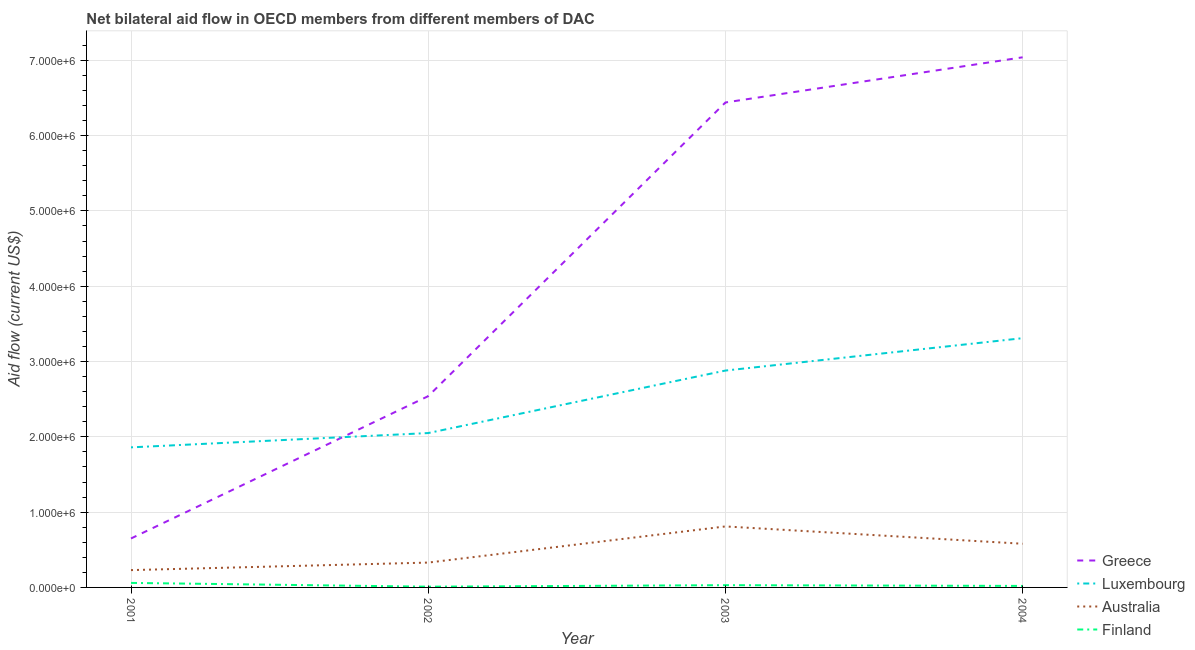Does the line corresponding to amount of aid given by luxembourg intersect with the line corresponding to amount of aid given by finland?
Offer a terse response. No. Is the number of lines equal to the number of legend labels?
Make the answer very short. Yes. What is the amount of aid given by australia in 2004?
Your answer should be very brief. 5.80e+05. Across all years, what is the maximum amount of aid given by finland?
Offer a very short reply. 6.00e+04. Across all years, what is the minimum amount of aid given by luxembourg?
Your response must be concise. 1.86e+06. In which year was the amount of aid given by greece minimum?
Your answer should be compact. 2001. What is the total amount of aid given by australia in the graph?
Give a very brief answer. 1.95e+06. What is the difference between the amount of aid given by luxembourg in 2002 and that in 2004?
Your answer should be compact. -1.26e+06. What is the difference between the amount of aid given by finland in 2002 and the amount of aid given by luxembourg in 2004?
Offer a very short reply. -3.30e+06. What is the average amount of aid given by luxembourg per year?
Provide a succinct answer. 2.52e+06. In the year 2001, what is the difference between the amount of aid given by luxembourg and amount of aid given by finland?
Offer a terse response. 1.80e+06. What is the ratio of the amount of aid given by finland in 2003 to that in 2004?
Make the answer very short. 1.5. Is the difference between the amount of aid given by luxembourg in 2001 and 2002 greater than the difference between the amount of aid given by greece in 2001 and 2002?
Provide a succinct answer. Yes. What is the difference between the highest and the lowest amount of aid given by luxembourg?
Your answer should be very brief. 1.45e+06. Is the sum of the amount of aid given by australia in 2001 and 2002 greater than the maximum amount of aid given by greece across all years?
Give a very brief answer. No. Is it the case that in every year, the sum of the amount of aid given by greece and amount of aid given by luxembourg is greater than the amount of aid given by australia?
Offer a terse response. Yes. Is the amount of aid given by australia strictly less than the amount of aid given by finland over the years?
Your response must be concise. No. How many lines are there?
Make the answer very short. 4. How many years are there in the graph?
Make the answer very short. 4. What is the difference between two consecutive major ticks on the Y-axis?
Provide a short and direct response. 1.00e+06. Does the graph contain any zero values?
Offer a very short reply. No. Does the graph contain grids?
Make the answer very short. Yes. How many legend labels are there?
Provide a short and direct response. 4. How are the legend labels stacked?
Make the answer very short. Vertical. What is the title of the graph?
Make the answer very short. Net bilateral aid flow in OECD members from different members of DAC. What is the label or title of the X-axis?
Give a very brief answer. Year. What is the label or title of the Y-axis?
Your answer should be compact. Aid flow (current US$). What is the Aid flow (current US$) of Greece in 2001?
Give a very brief answer. 6.50e+05. What is the Aid flow (current US$) of Luxembourg in 2001?
Your answer should be very brief. 1.86e+06. What is the Aid flow (current US$) of Australia in 2001?
Give a very brief answer. 2.30e+05. What is the Aid flow (current US$) in Finland in 2001?
Give a very brief answer. 6.00e+04. What is the Aid flow (current US$) of Greece in 2002?
Your answer should be compact. 2.54e+06. What is the Aid flow (current US$) of Luxembourg in 2002?
Your answer should be very brief. 2.05e+06. What is the Aid flow (current US$) of Australia in 2002?
Your answer should be compact. 3.30e+05. What is the Aid flow (current US$) in Finland in 2002?
Offer a very short reply. 10000. What is the Aid flow (current US$) in Greece in 2003?
Your response must be concise. 6.44e+06. What is the Aid flow (current US$) of Luxembourg in 2003?
Offer a terse response. 2.88e+06. What is the Aid flow (current US$) in Australia in 2003?
Make the answer very short. 8.10e+05. What is the Aid flow (current US$) in Greece in 2004?
Provide a succinct answer. 7.04e+06. What is the Aid flow (current US$) in Luxembourg in 2004?
Your response must be concise. 3.31e+06. What is the Aid flow (current US$) in Australia in 2004?
Offer a terse response. 5.80e+05. What is the Aid flow (current US$) in Finland in 2004?
Offer a very short reply. 2.00e+04. Across all years, what is the maximum Aid flow (current US$) in Greece?
Give a very brief answer. 7.04e+06. Across all years, what is the maximum Aid flow (current US$) of Luxembourg?
Provide a short and direct response. 3.31e+06. Across all years, what is the maximum Aid flow (current US$) in Australia?
Offer a terse response. 8.10e+05. Across all years, what is the maximum Aid flow (current US$) of Finland?
Give a very brief answer. 6.00e+04. Across all years, what is the minimum Aid flow (current US$) in Greece?
Ensure brevity in your answer.  6.50e+05. Across all years, what is the minimum Aid flow (current US$) of Luxembourg?
Offer a very short reply. 1.86e+06. What is the total Aid flow (current US$) in Greece in the graph?
Your answer should be very brief. 1.67e+07. What is the total Aid flow (current US$) in Luxembourg in the graph?
Make the answer very short. 1.01e+07. What is the total Aid flow (current US$) in Australia in the graph?
Offer a terse response. 1.95e+06. What is the total Aid flow (current US$) of Finland in the graph?
Ensure brevity in your answer.  1.20e+05. What is the difference between the Aid flow (current US$) in Greece in 2001 and that in 2002?
Offer a very short reply. -1.89e+06. What is the difference between the Aid flow (current US$) in Luxembourg in 2001 and that in 2002?
Provide a succinct answer. -1.90e+05. What is the difference between the Aid flow (current US$) in Greece in 2001 and that in 2003?
Provide a short and direct response. -5.79e+06. What is the difference between the Aid flow (current US$) of Luxembourg in 2001 and that in 2003?
Offer a very short reply. -1.02e+06. What is the difference between the Aid flow (current US$) in Australia in 2001 and that in 2003?
Ensure brevity in your answer.  -5.80e+05. What is the difference between the Aid flow (current US$) in Finland in 2001 and that in 2003?
Offer a very short reply. 3.00e+04. What is the difference between the Aid flow (current US$) in Greece in 2001 and that in 2004?
Offer a very short reply. -6.39e+06. What is the difference between the Aid flow (current US$) of Luxembourg in 2001 and that in 2004?
Your response must be concise. -1.45e+06. What is the difference between the Aid flow (current US$) of Australia in 2001 and that in 2004?
Make the answer very short. -3.50e+05. What is the difference between the Aid flow (current US$) in Greece in 2002 and that in 2003?
Your answer should be compact. -3.90e+06. What is the difference between the Aid flow (current US$) of Luxembourg in 2002 and that in 2003?
Offer a very short reply. -8.30e+05. What is the difference between the Aid flow (current US$) in Australia in 2002 and that in 2003?
Ensure brevity in your answer.  -4.80e+05. What is the difference between the Aid flow (current US$) in Greece in 2002 and that in 2004?
Provide a succinct answer. -4.50e+06. What is the difference between the Aid flow (current US$) of Luxembourg in 2002 and that in 2004?
Your answer should be very brief. -1.26e+06. What is the difference between the Aid flow (current US$) in Greece in 2003 and that in 2004?
Make the answer very short. -6.00e+05. What is the difference between the Aid flow (current US$) in Luxembourg in 2003 and that in 2004?
Your response must be concise. -4.30e+05. What is the difference between the Aid flow (current US$) of Australia in 2003 and that in 2004?
Your answer should be very brief. 2.30e+05. What is the difference between the Aid flow (current US$) of Greece in 2001 and the Aid flow (current US$) of Luxembourg in 2002?
Make the answer very short. -1.40e+06. What is the difference between the Aid flow (current US$) of Greece in 2001 and the Aid flow (current US$) of Finland in 2002?
Provide a succinct answer. 6.40e+05. What is the difference between the Aid flow (current US$) of Luxembourg in 2001 and the Aid flow (current US$) of Australia in 2002?
Your answer should be very brief. 1.53e+06. What is the difference between the Aid flow (current US$) of Luxembourg in 2001 and the Aid flow (current US$) of Finland in 2002?
Give a very brief answer. 1.85e+06. What is the difference between the Aid flow (current US$) of Greece in 2001 and the Aid flow (current US$) of Luxembourg in 2003?
Your answer should be very brief. -2.23e+06. What is the difference between the Aid flow (current US$) of Greece in 2001 and the Aid flow (current US$) of Australia in 2003?
Offer a very short reply. -1.60e+05. What is the difference between the Aid flow (current US$) of Greece in 2001 and the Aid flow (current US$) of Finland in 2003?
Give a very brief answer. 6.20e+05. What is the difference between the Aid flow (current US$) of Luxembourg in 2001 and the Aid flow (current US$) of Australia in 2003?
Your response must be concise. 1.05e+06. What is the difference between the Aid flow (current US$) of Luxembourg in 2001 and the Aid flow (current US$) of Finland in 2003?
Your answer should be very brief. 1.83e+06. What is the difference between the Aid flow (current US$) in Australia in 2001 and the Aid flow (current US$) in Finland in 2003?
Make the answer very short. 2.00e+05. What is the difference between the Aid flow (current US$) in Greece in 2001 and the Aid flow (current US$) in Luxembourg in 2004?
Give a very brief answer. -2.66e+06. What is the difference between the Aid flow (current US$) in Greece in 2001 and the Aid flow (current US$) in Finland in 2004?
Provide a short and direct response. 6.30e+05. What is the difference between the Aid flow (current US$) of Luxembourg in 2001 and the Aid flow (current US$) of Australia in 2004?
Your answer should be compact. 1.28e+06. What is the difference between the Aid flow (current US$) of Luxembourg in 2001 and the Aid flow (current US$) of Finland in 2004?
Provide a short and direct response. 1.84e+06. What is the difference between the Aid flow (current US$) of Australia in 2001 and the Aid flow (current US$) of Finland in 2004?
Offer a terse response. 2.10e+05. What is the difference between the Aid flow (current US$) in Greece in 2002 and the Aid flow (current US$) in Australia in 2003?
Offer a terse response. 1.73e+06. What is the difference between the Aid flow (current US$) of Greece in 2002 and the Aid flow (current US$) of Finland in 2003?
Provide a succinct answer. 2.51e+06. What is the difference between the Aid flow (current US$) in Luxembourg in 2002 and the Aid flow (current US$) in Australia in 2003?
Make the answer very short. 1.24e+06. What is the difference between the Aid flow (current US$) in Luxembourg in 2002 and the Aid flow (current US$) in Finland in 2003?
Offer a very short reply. 2.02e+06. What is the difference between the Aid flow (current US$) of Greece in 2002 and the Aid flow (current US$) of Luxembourg in 2004?
Offer a terse response. -7.70e+05. What is the difference between the Aid flow (current US$) of Greece in 2002 and the Aid flow (current US$) of Australia in 2004?
Give a very brief answer. 1.96e+06. What is the difference between the Aid flow (current US$) in Greece in 2002 and the Aid flow (current US$) in Finland in 2004?
Provide a succinct answer. 2.52e+06. What is the difference between the Aid flow (current US$) of Luxembourg in 2002 and the Aid flow (current US$) of Australia in 2004?
Make the answer very short. 1.47e+06. What is the difference between the Aid flow (current US$) of Luxembourg in 2002 and the Aid flow (current US$) of Finland in 2004?
Your response must be concise. 2.03e+06. What is the difference between the Aid flow (current US$) of Australia in 2002 and the Aid flow (current US$) of Finland in 2004?
Give a very brief answer. 3.10e+05. What is the difference between the Aid flow (current US$) of Greece in 2003 and the Aid flow (current US$) of Luxembourg in 2004?
Offer a terse response. 3.13e+06. What is the difference between the Aid flow (current US$) of Greece in 2003 and the Aid flow (current US$) of Australia in 2004?
Provide a succinct answer. 5.86e+06. What is the difference between the Aid flow (current US$) of Greece in 2003 and the Aid flow (current US$) of Finland in 2004?
Your answer should be very brief. 6.42e+06. What is the difference between the Aid flow (current US$) of Luxembourg in 2003 and the Aid flow (current US$) of Australia in 2004?
Give a very brief answer. 2.30e+06. What is the difference between the Aid flow (current US$) of Luxembourg in 2003 and the Aid flow (current US$) of Finland in 2004?
Keep it short and to the point. 2.86e+06. What is the difference between the Aid flow (current US$) in Australia in 2003 and the Aid flow (current US$) in Finland in 2004?
Offer a terse response. 7.90e+05. What is the average Aid flow (current US$) in Greece per year?
Offer a very short reply. 4.17e+06. What is the average Aid flow (current US$) in Luxembourg per year?
Ensure brevity in your answer.  2.52e+06. What is the average Aid flow (current US$) in Australia per year?
Provide a short and direct response. 4.88e+05. What is the average Aid flow (current US$) of Finland per year?
Give a very brief answer. 3.00e+04. In the year 2001, what is the difference between the Aid flow (current US$) of Greece and Aid flow (current US$) of Luxembourg?
Your answer should be very brief. -1.21e+06. In the year 2001, what is the difference between the Aid flow (current US$) of Greece and Aid flow (current US$) of Finland?
Provide a succinct answer. 5.90e+05. In the year 2001, what is the difference between the Aid flow (current US$) of Luxembourg and Aid flow (current US$) of Australia?
Your answer should be very brief. 1.63e+06. In the year 2001, what is the difference between the Aid flow (current US$) in Luxembourg and Aid flow (current US$) in Finland?
Your response must be concise. 1.80e+06. In the year 2001, what is the difference between the Aid flow (current US$) of Australia and Aid flow (current US$) of Finland?
Ensure brevity in your answer.  1.70e+05. In the year 2002, what is the difference between the Aid flow (current US$) of Greece and Aid flow (current US$) of Luxembourg?
Offer a very short reply. 4.90e+05. In the year 2002, what is the difference between the Aid flow (current US$) of Greece and Aid flow (current US$) of Australia?
Ensure brevity in your answer.  2.21e+06. In the year 2002, what is the difference between the Aid flow (current US$) of Greece and Aid flow (current US$) of Finland?
Offer a terse response. 2.53e+06. In the year 2002, what is the difference between the Aid flow (current US$) of Luxembourg and Aid flow (current US$) of Australia?
Your answer should be compact. 1.72e+06. In the year 2002, what is the difference between the Aid flow (current US$) of Luxembourg and Aid flow (current US$) of Finland?
Your answer should be very brief. 2.04e+06. In the year 2002, what is the difference between the Aid flow (current US$) of Australia and Aid flow (current US$) of Finland?
Provide a succinct answer. 3.20e+05. In the year 2003, what is the difference between the Aid flow (current US$) in Greece and Aid flow (current US$) in Luxembourg?
Your response must be concise. 3.56e+06. In the year 2003, what is the difference between the Aid flow (current US$) of Greece and Aid flow (current US$) of Australia?
Provide a succinct answer. 5.63e+06. In the year 2003, what is the difference between the Aid flow (current US$) of Greece and Aid flow (current US$) of Finland?
Provide a short and direct response. 6.41e+06. In the year 2003, what is the difference between the Aid flow (current US$) in Luxembourg and Aid flow (current US$) in Australia?
Make the answer very short. 2.07e+06. In the year 2003, what is the difference between the Aid flow (current US$) of Luxembourg and Aid flow (current US$) of Finland?
Make the answer very short. 2.85e+06. In the year 2003, what is the difference between the Aid flow (current US$) in Australia and Aid flow (current US$) in Finland?
Offer a very short reply. 7.80e+05. In the year 2004, what is the difference between the Aid flow (current US$) of Greece and Aid flow (current US$) of Luxembourg?
Keep it short and to the point. 3.73e+06. In the year 2004, what is the difference between the Aid flow (current US$) of Greece and Aid flow (current US$) of Australia?
Keep it short and to the point. 6.46e+06. In the year 2004, what is the difference between the Aid flow (current US$) in Greece and Aid flow (current US$) in Finland?
Your response must be concise. 7.02e+06. In the year 2004, what is the difference between the Aid flow (current US$) of Luxembourg and Aid flow (current US$) of Australia?
Ensure brevity in your answer.  2.73e+06. In the year 2004, what is the difference between the Aid flow (current US$) in Luxembourg and Aid flow (current US$) in Finland?
Provide a short and direct response. 3.29e+06. In the year 2004, what is the difference between the Aid flow (current US$) of Australia and Aid flow (current US$) of Finland?
Your answer should be very brief. 5.60e+05. What is the ratio of the Aid flow (current US$) in Greece in 2001 to that in 2002?
Keep it short and to the point. 0.26. What is the ratio of the Aid flow (current US$) of Luxembourg in 2001 to that in 2002?
Your answer should be very brief. 0.91. What is the ratio of the Aid flow (current US$) of Australia in 2001 to that in 2002?
Make the answer very short. 0.7. What is the ratio of the Aid flow (current US$) of Finland in 2001 to that in 2002?
Your response must be concise. 6. What is the ratio of the Aid flow (current US$) in Greece in 2001 to that in 2003?
Provide a short and direct response. 0.1. What is the ratio of the Aid flow (current US$) in Luxembourg in 2001 to that in 2003?
Offer a terse response. 0.65. What is the ratio of the Aid flow (current US$) in Australia in 2001 to that in 2003?
Give a very brief answer. 0.28. What is the ratio of the Aid flow (current US$) of Greece in 2001 to that in 2004?
Provide a short and direct response. 0.09. What is the ratio of the Aid flow (current US$) of Luxembourg in 2001 to that in 2004?
Offer a very short reply. 0.56. What is the ratio of the Aid flow (current US$) in Australia in 2001 to that in 2004?
Offer a terse response. 0.4. What is the ratio of the Aid flow (current US$) in Greece in 2002 to that in 2003?
Give a very brief answer. 0.39. What is the ratio of the Aid flow (current US$) of Luxembourg in 2002 to that in 2003?
Offer a terse response. 0.71. What is the ratio of the Aid flow (current US$) of Australia in 2002 to that in 2003?
Offer a terse response. 0.41. What is the ratio of the Aid flow (current US$) in Finland in 2002 to that in 2003?
Keep it short and to the point. 0.33. What is the ratio of the Aid flow (current US$) of Greece in 2002 to that in 2004?
Your response must be concise. 0.36. What is the ratio of the Aid flow (current US$) in Luxembourg in 2002 to that in 2004?
Give a very brief answer. 0.62. What is the ratio of the Aid flow (current US$) of Australia in 2002 to that in 2004?
Keep it short and to the point. 0.57. What is the ratio of the Aid flow (current US$) in Greece in 2003 to that in 2004?
Ensure brevity in your answer.  0.91. What is the ratio of the Aid flow (current US$) of Luxembourg in 2003 to that in 2004?
Your answer should be compact. 0.87. What is the ratio of the Aid flow (current US$) of Australia in 2003 to that in 2004?
Provide a succinct answer. 1.4. What is the difference between the highest and the second highest Aid flow (current US$) in Luxembourg?
Offer a very short reply. 4.30e+05. What is the difference between the highest and the lowest Aid flow (current US$) in Greece?
Give a very brief answer. 6.39e+06. What is the difference between the highest and the lowest Aid flow (current US$) in Luxembourg?
Give a very brief answer. 1.45e+06. What is the difference between the highest and the lowest Aid flow (current US$) of Australia?
Offer a very short reply. 5.80e+05. What is the difference between the highest and the lowest Aid flow (current US$) in Finland?
Provide a short and direct response. 5.00e+04. 